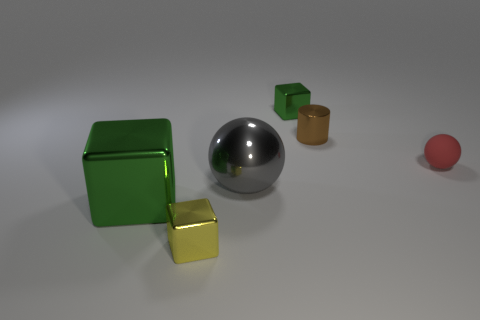How many small objects are there?
Provide a short and direct response. 4. There is a tiny cube behind the big gray sphere; what is its color?
Keep it short and to the point. Green. The rubber ball has what size?
Provide a short and direct response. Small. Is the color of the small rubber thing the same as the block behind the big block?
Your response must be concise. No. What color is the tiny thing in front of the big shiny block that is to the left of the small sphere?
Provide a succinct answer. Yellow. Are there any other things that have the same size as the gray object?
Make the answer very short. Yes. Do the green metallic object that is in front of the shiny cylinder and the large gray object have the same shape?
Your response must be concise. No. What number of things are both to the left of the small red sphere and in front of the tiny brown shiny object?
Provide a succinct answer. 3. What is the color of the small object left of the tiny metallic cube that is behind the green metallic thing that is in front of the gray ball?
Provide a short and direct response. Yellow. There is a cube right of the tiny yellow object; what number of cubes are to the right of it?
Keep it short and to the point. 0. 